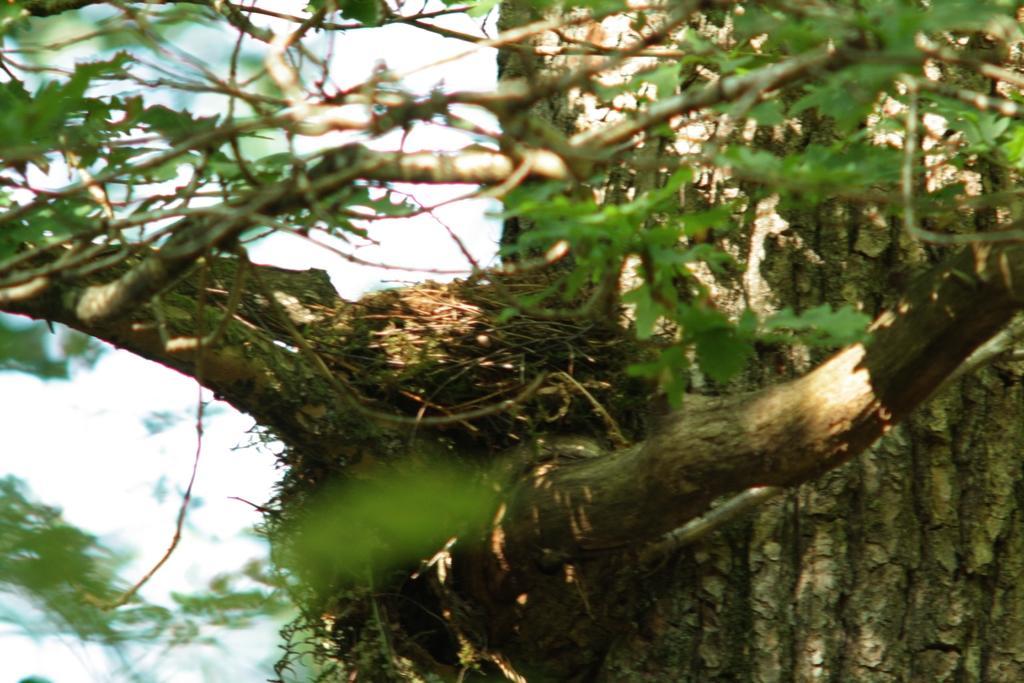In one or two sentences, can you explain what this image depicts? In this picture there is a nest in the center of the image and there is greenery in the image. 